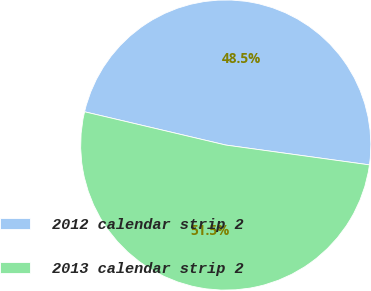Convert chart. <chart><loc_0><loc_0><loc_500><loc_500><pie_chart><fcel>2012 calendar strip 2<fcel>2013 calendar strip 2<nl><fcel>48.5%<fcel>51.5%<nl></chart> 